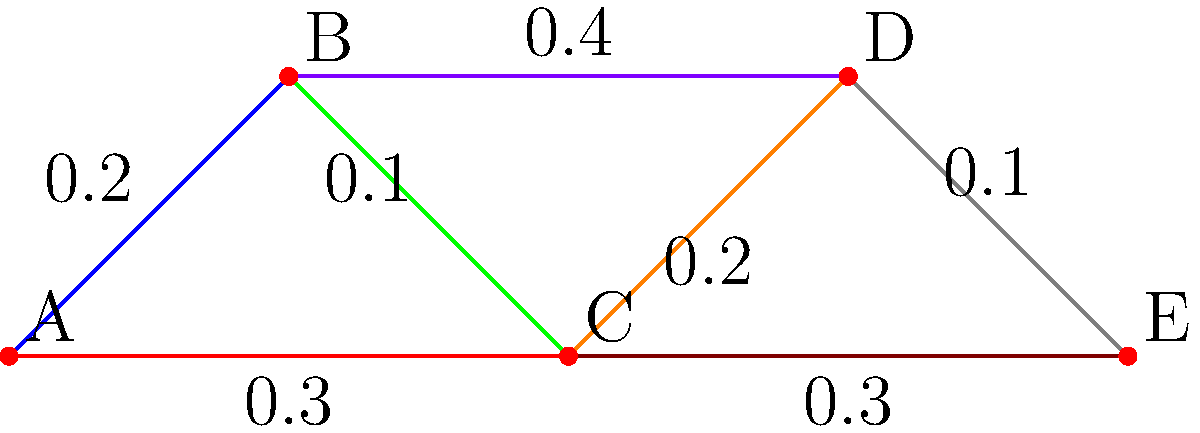In a portfolio optimization problem, you need to create a minimum spanning tree to minimize risk while maximizing returns. The graph represents different assets (nodes) and their correlations (edge weights). What is the total weight of the minimum spanning tree for this portfolio, and which edges should be included to achieve optimal risk-adjusted returns? To solve this problem, we'll use Kruskal's algorithm to find the minimum spanning tree:

1. Sort the edges by weight in ascending order:
   (B-C): 0.1
   (D-E): 0.1
   (A-B): 0.2
   (C-D): 0.2
   (A-C): 0.3
   (C-E): 0.3
   (B-D): 0.4

2. Start with an empty set of edges and add edges in order, skipping those that would create a cycle:
   - Add (B-C): 0.1
   - Add (D-E): 0.1
   - Add (A-B): 0.2
   - Add (C-D): 0.2

3. We now have 4 edges, which is enough to connect all 5 vertices without creating cycles.

4. The minimum spanning tree includes the edges:
   (B-C), (D-E), (A-B), and (C-D)

5. Calculate the total weight:
   0.1 + 0.1 + 0.2 + 0.2 = 0.6

The minimum spanning tree with a total weight of 0.6 represents the optimal portfolio structure that minimizes risk (correlation) while maintaining connectivity between all assets.
Answer: Total weight: 0.6; Edges: (B-C), (D-E), (A-B), (C-D) 